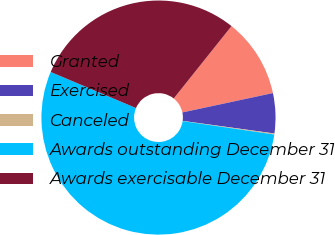Convert chart to OTSL. <chart><loc_0><loc_0><loc_500><loc_500><pie_chart><fcel>Granted<fcel>Exercised<fcel>Canceled<fcel>Awards outstanding December 31<fcel>Awards exercisable December 31<nl><fcel>10.92%<fcel>5.53%<fcel>0.14%<fcel>54.06%<fcel>29.36%<nl></chart> 